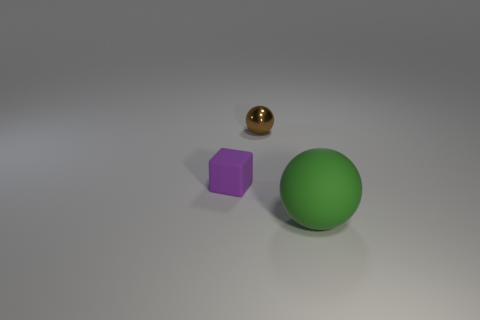How many objects are small purple matte things that are to the left of the large green sphere or brown rubber objects?
Offer a very short reply. 1. Do the matte cube and the brown ball have the same size?
Make the answer very short. Yes. The rubber thing that is on the right side of the brown metal sphere is what color?
Provide a short and direct response. Green. What is the size of the green object that is made of the same material as the small purple block?
Provide a succinct answer. Large. Do the brown metal sphere and the rubber object to the right of the small cube have the same size?
Provide a short and direct response. No. What is the tiny thing to the right of the matte cube made of?
Provide a short and direct response. Metal. What number of small matte blocks are in front of the rubber object that is on the right side of the purple object?
Your answer should be compact. 0. Is there a small purple matte object of the same shape as the brown metal thing?
Offer a very short reply. No. Is the size of the thing that is behind the small purple cube the same as the rubber thing behind the green rubber object?
Give a very brief answer. Yes. There is a object that is in front of the matte thing to the left of the big green matte ball; what shape is it?
Keep it short and to the point. Sphere. 